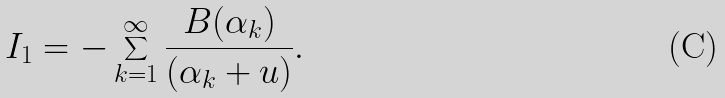Convert formula to latex. <formula><loc_0><loc_0><loc_500><loc_500>I _ { 1 } = - \sum _ { k = 1 } ^ { \infty } \frac { B ( \alpha _ { k } ) } { ( \alpha _ { k } + u ) } .</formula> 